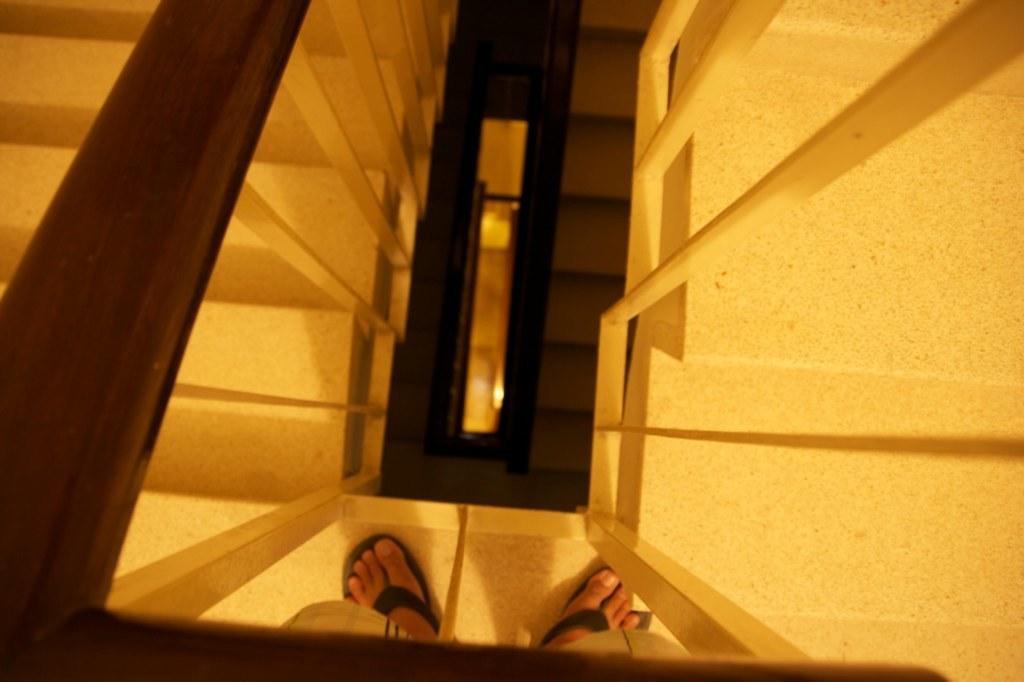Please provide a concise description of this image. On the bottom, there are legs of a person and railing. On the left and right, there are stairs and railing. In the background, we can see stairs and the railing. 